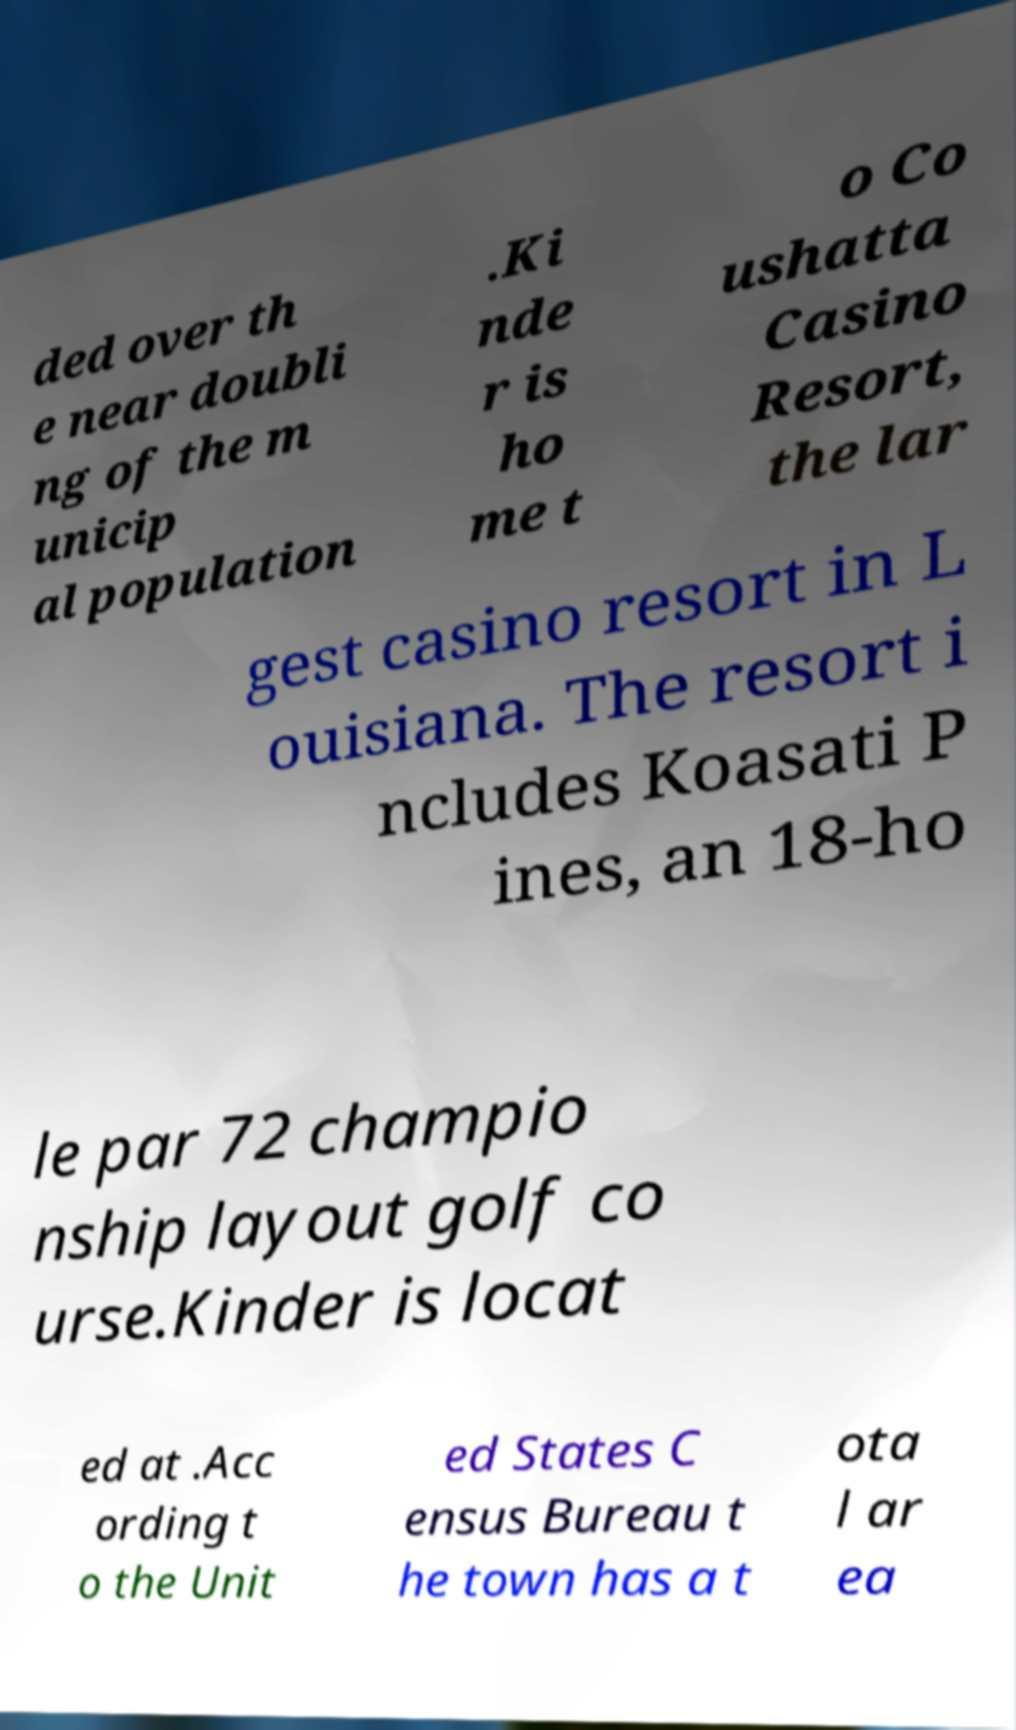Could you extract and type out the text from this image? ded over th e near doubli ng of the m unicip al population .Ki nde r is ho me t o Co ushatta Casino Resort, the lar gest casino resort in L ouisiana. The resort i ncludes Koasati P ines, an 18-ho le par 72 champio nship layout golf co urse.Kinder is locat ed at .Acc ording t o the Unit ed States C ensus Bureau t he town has a t ota l ar ea 